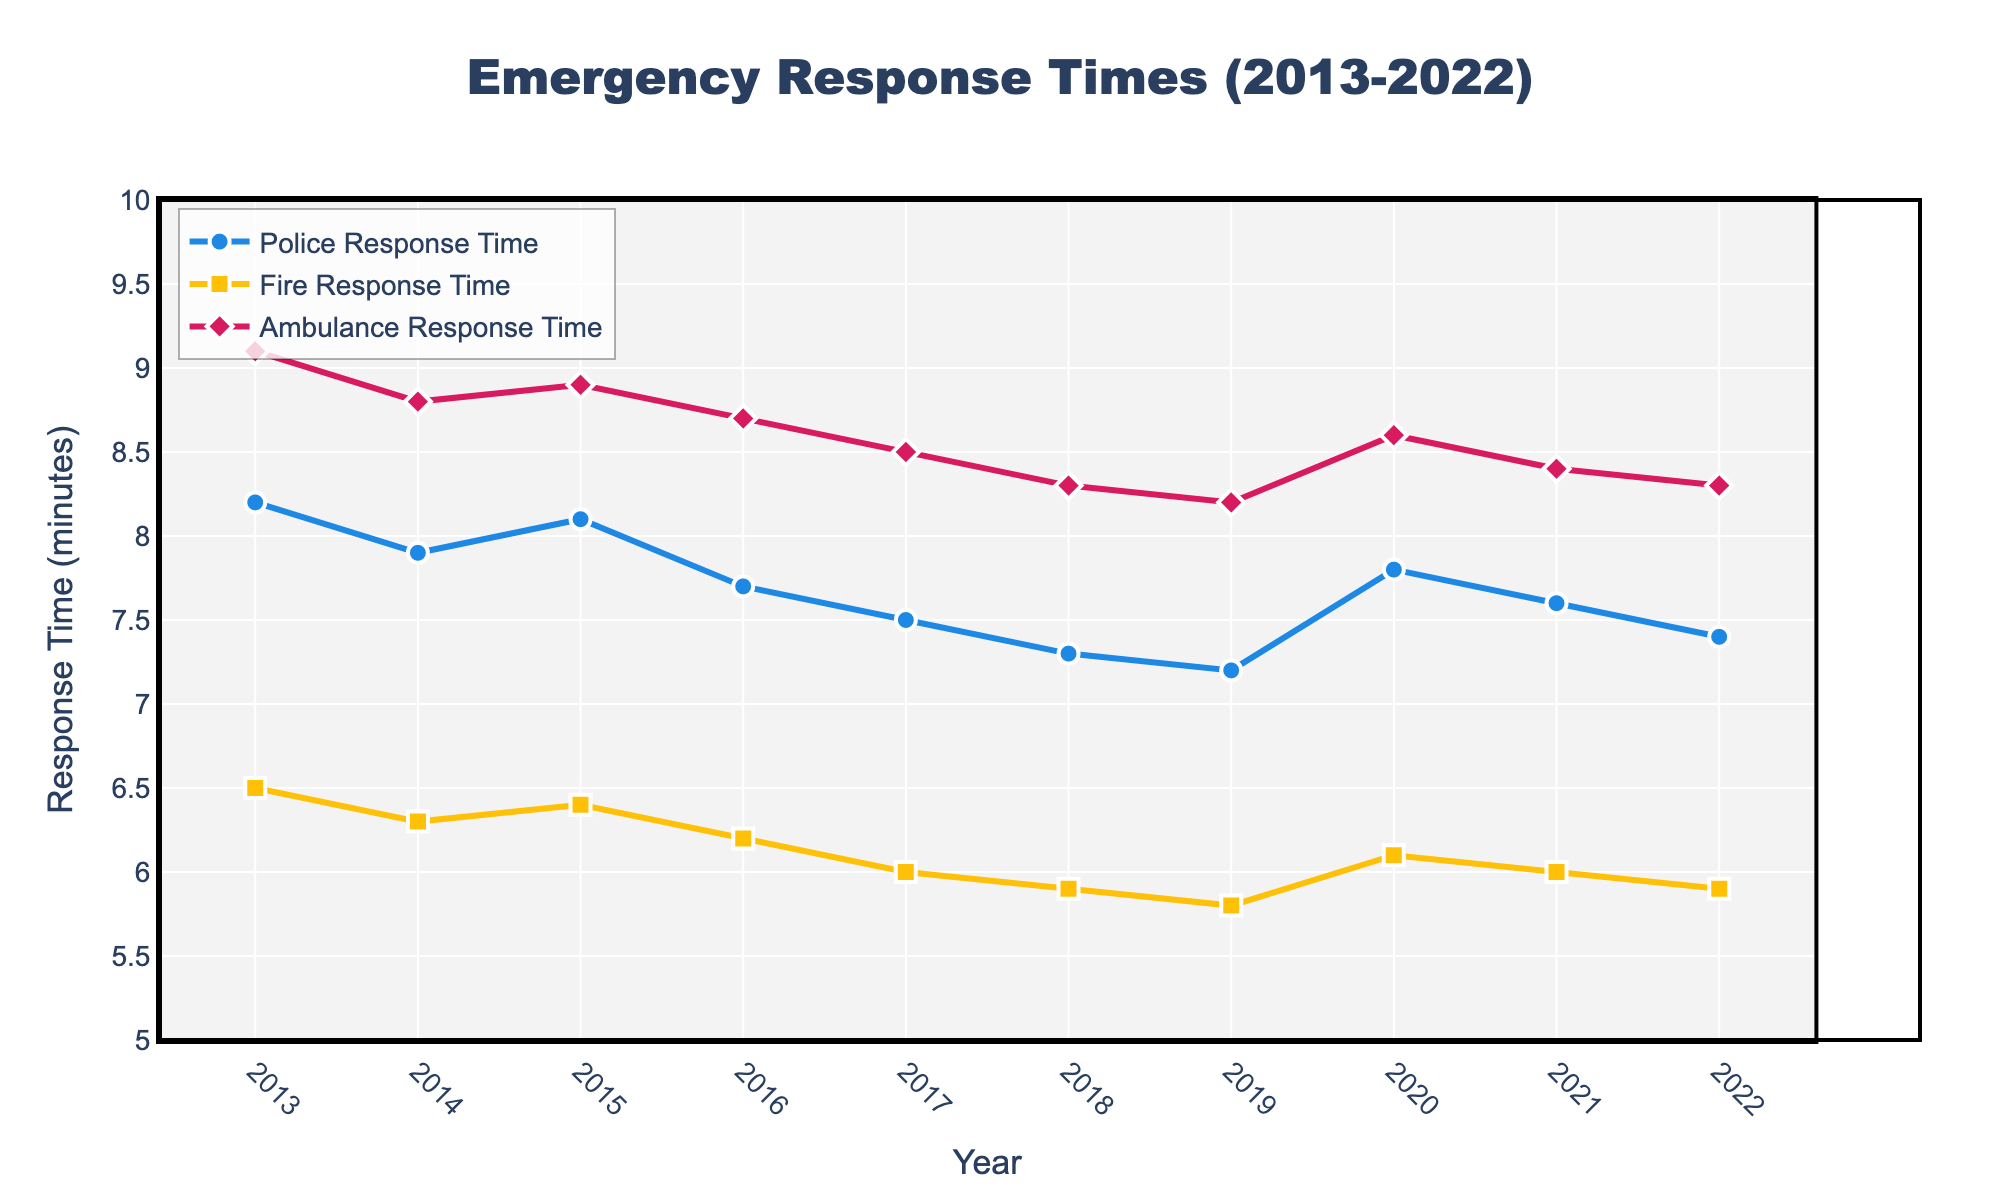Which service had the lowest response time in 2022? Look at the data points for 2022. Compare the response times for police, fire, and ambulance services. The fire service has a response time of 5.9 minutes, which is the lowest.
Answer: Fire How did the ambulance response time change from 2013 to 2022? Subtract the response time in 2022 from the response time in 2013 for the ambulance service. The change is 9.1 - 8.3 = 0.8 minutes.
Answer: Decreased by 0.8 minutes What year had the highest police response time? Look at the police response times across all years and identify the highest value. The highest police response time is 8.2 minutes in 2013.
Answer: 2013 Compare the trend of fire response times with police response times over the decade. Observe the line trends for both fire and police response times from 2013 to 2022. Fire response times consistently decreased, while police response times varied, initially decreased, then increased around 2020, and finally decreased again.
Answer: Fire consistently decreased; police varied Calculate the average response time for fire services from 2013 to 2022. Sum all fire response times from 2013 to 2022 and divide by the number of years. (6.5 + 6.3 + 6.4 + 6.2 + 6.0 + 5.9 + 5.8 + 6.1 + 6.0 + 5.9) / 10 = 6.11 minutes.
Answer: 6.11 minutes Which service showed the most consistent improvement over time? Compare the overall trend for each service. The fire service shows a steady decline with minor year-on-year changes, indicating the most consistent improvement.
Answer: Fire In which year did police response times increase the most compared to the previous year? Subtract the previous year's response time from each year's response time for the police service. The largest increase is from 2019 to 2020 (7.8 - 7.2 = 0.6).
Answer: 2020 Determine the most significant year-to-year decrease in ambulance response time. Calculate the difference between each consecutive year's ambulance response time and identify the largest decrease. The decrease from 2019 to 2020 is the most significant (8.6 - 8.2 = 0.4).
Answer: 2020 